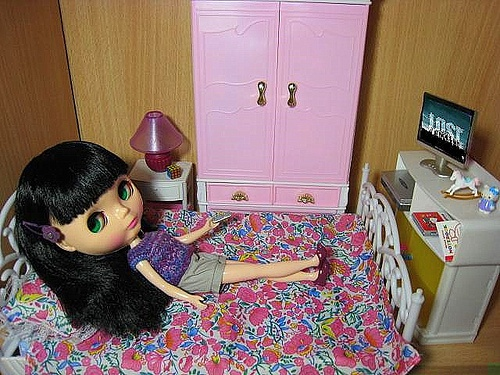Describe the objects in this image and their specific colors. I can see bed in maroon, brown, darkgray, gray, and lavender tones, tv in maroon, black, teal, gray, and white tones, book in maroon, lightgray, darkgray, and gray tones, book in maroon, brown, and gray tones, and horse in maroon, lightgray, darkgray, and gray tones in this image. 